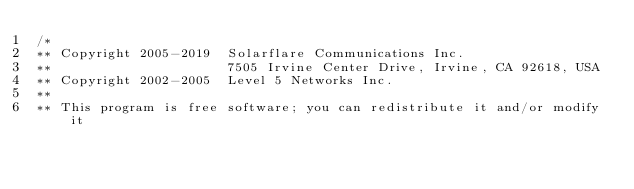Convert code to text. <code><loc_0><loc_0><loc_500><loc_500><_C_>/*
** Copyright 2005-2019  Solarflare Communications Inc.
**                      7505 Irvine Center Drive, Irvine, CA 92618, USA
** Copyright 2002-2005  Level 5 Networks Inc.
**
** This program is free software; you can redistribute it and/or modify it</code> 